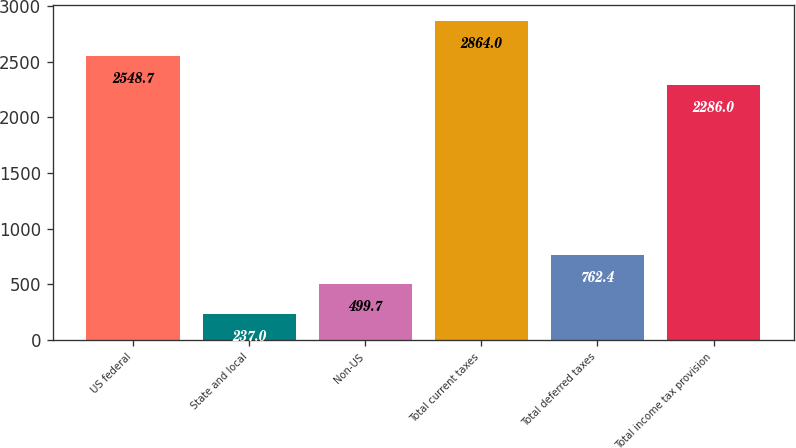Convert chart. <chart><loc_0><loc_0><loc_500><loc_500><bar_chart><fcel>US federal<fcel>State and local<fcel>Non-US<fcel>Total current taxes<fcel>Total deferred taxes<fcel>Total income tax provision<nl><fcel>2548.7<fcel>237<fcel>499.7<fcel>2864<fcel>762.4<fcel>2286<nl></chart> 